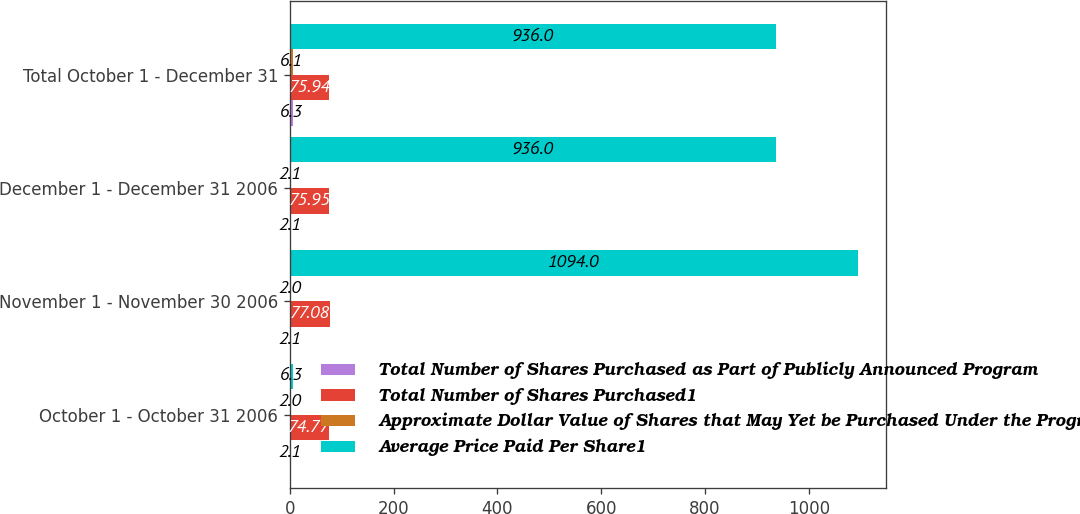<chart> <loc_0><loc_0><loc_500><loc_500><stacked_bar_chart><ecel><fcel>October 1 - October 31 2006<fcel>November 1 - November 30 2006<fcel>December 1 - December 31 2006<fcel>Total October 1 - December 31<nl><fcel>Total Number of Shares Purchased as Part of Publicly Announced Program<fcel>2.1<fcel>2.1<fcel>2.1<fcel>6.3<nl><fcel>Total Number of Shares Purchased1<fcel>74.77<fcel>77.08<fcel>75.95<fcel>75.94<nl><fcel>Approximate Dollar Value of Shares that May Yet be Purchased Under the Program<fcel>2<fcel>2<fcel>2.1<fcel>6.1<nl><fcel>Average Price Paid Per Share1<fcel>6.3<fcel>1094<fcel>936<fcel>936<nl></chart> 